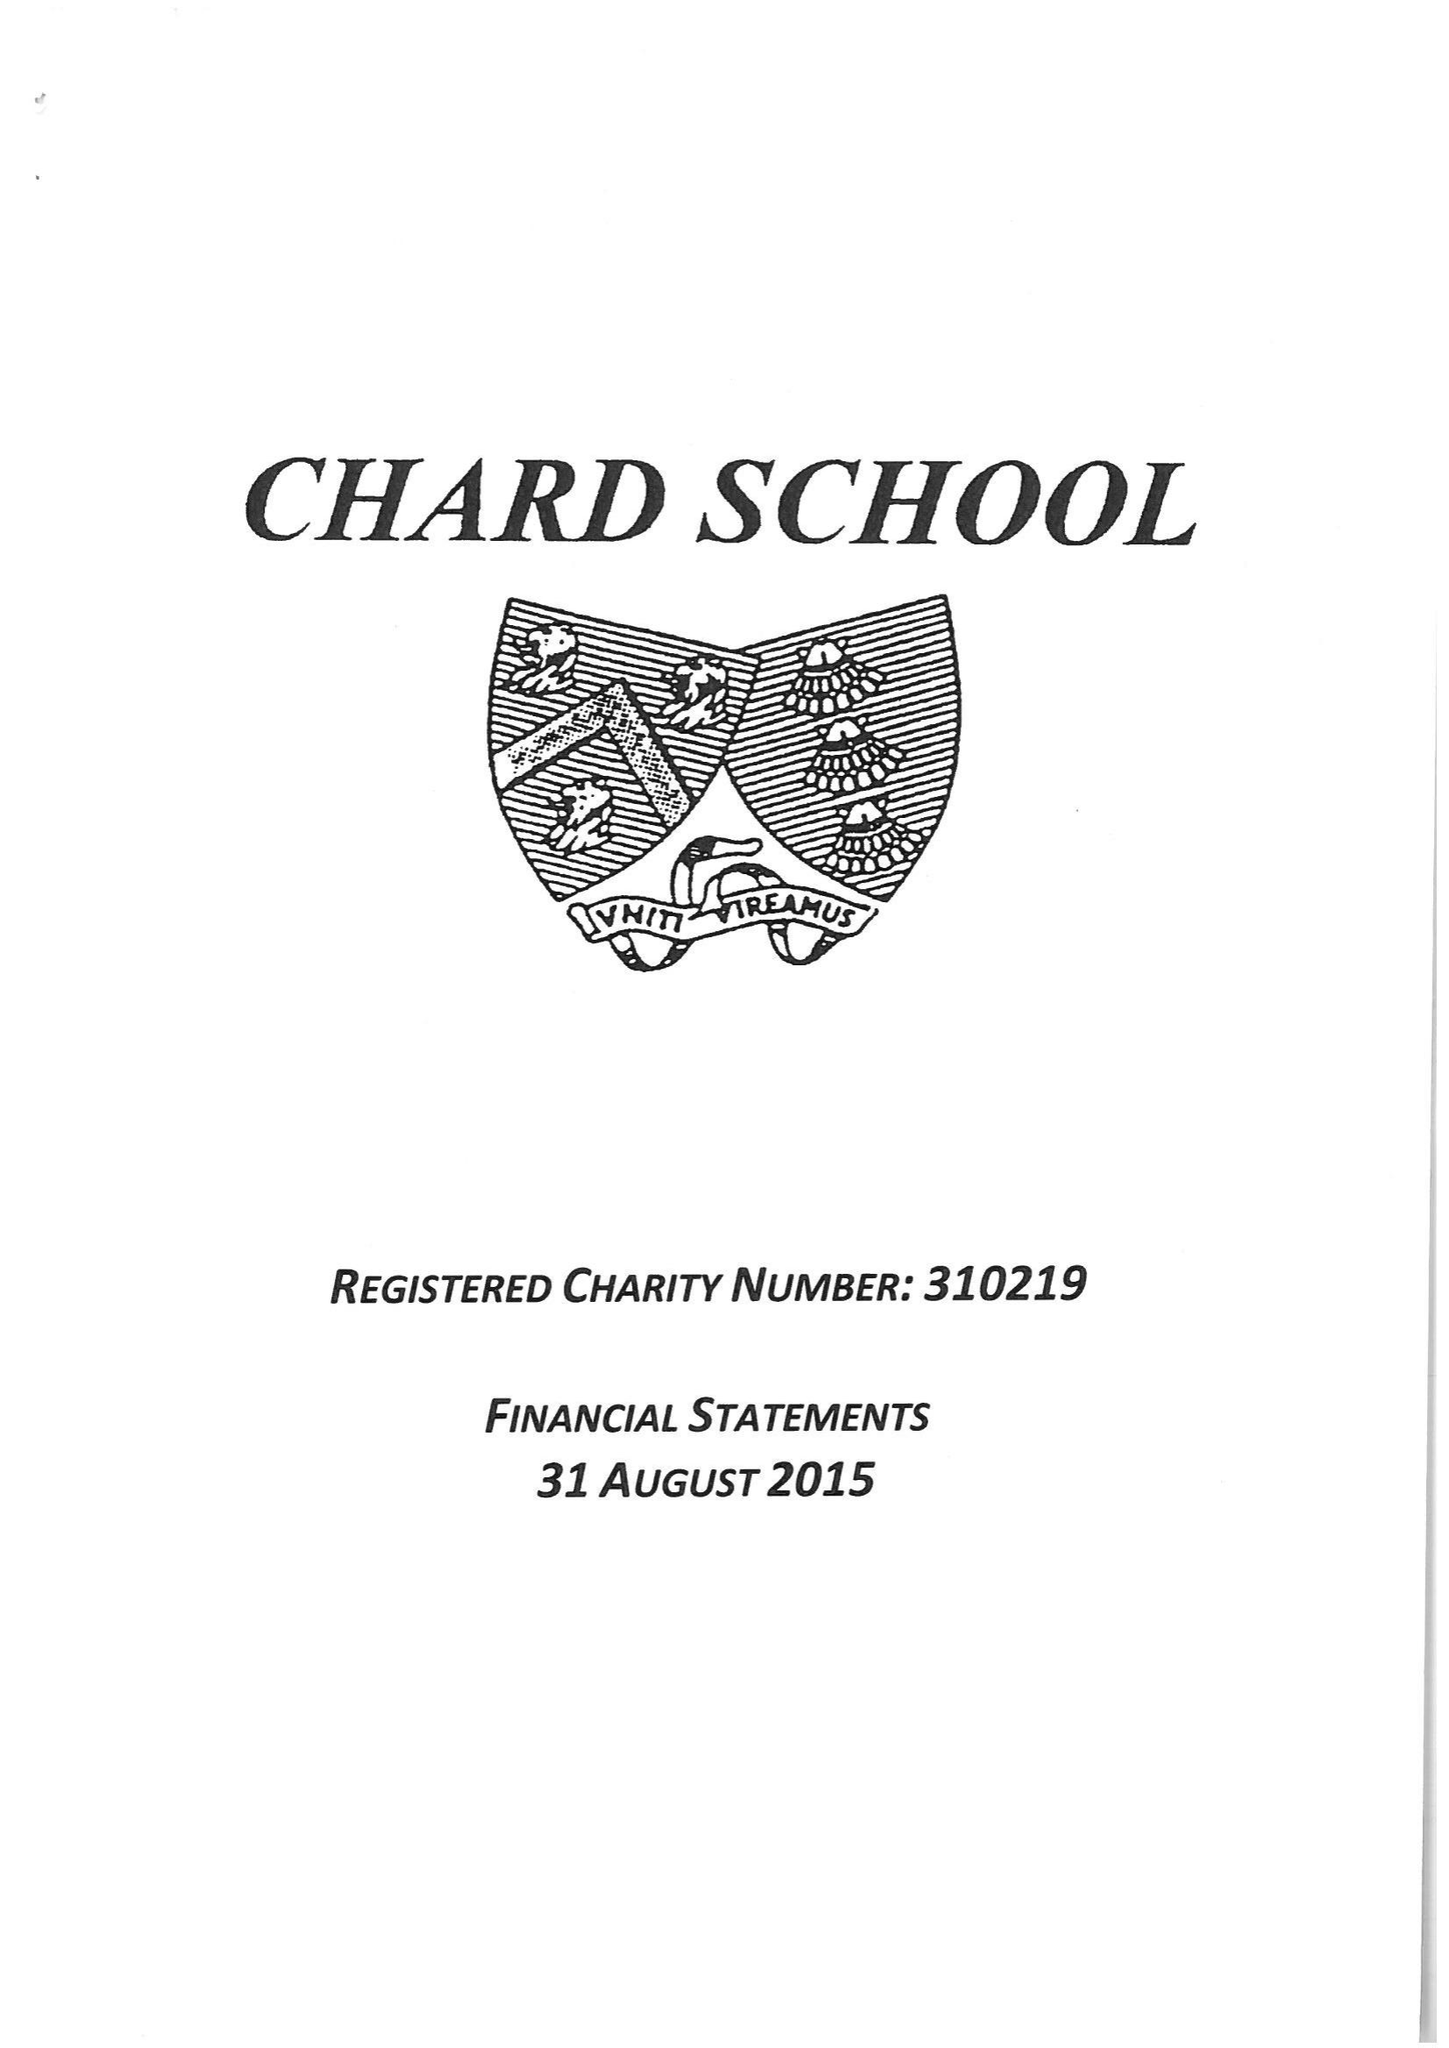What is the value for the spending_annually_in_british_pounds?
Answer the question using a single word or phrase. 384552.00 